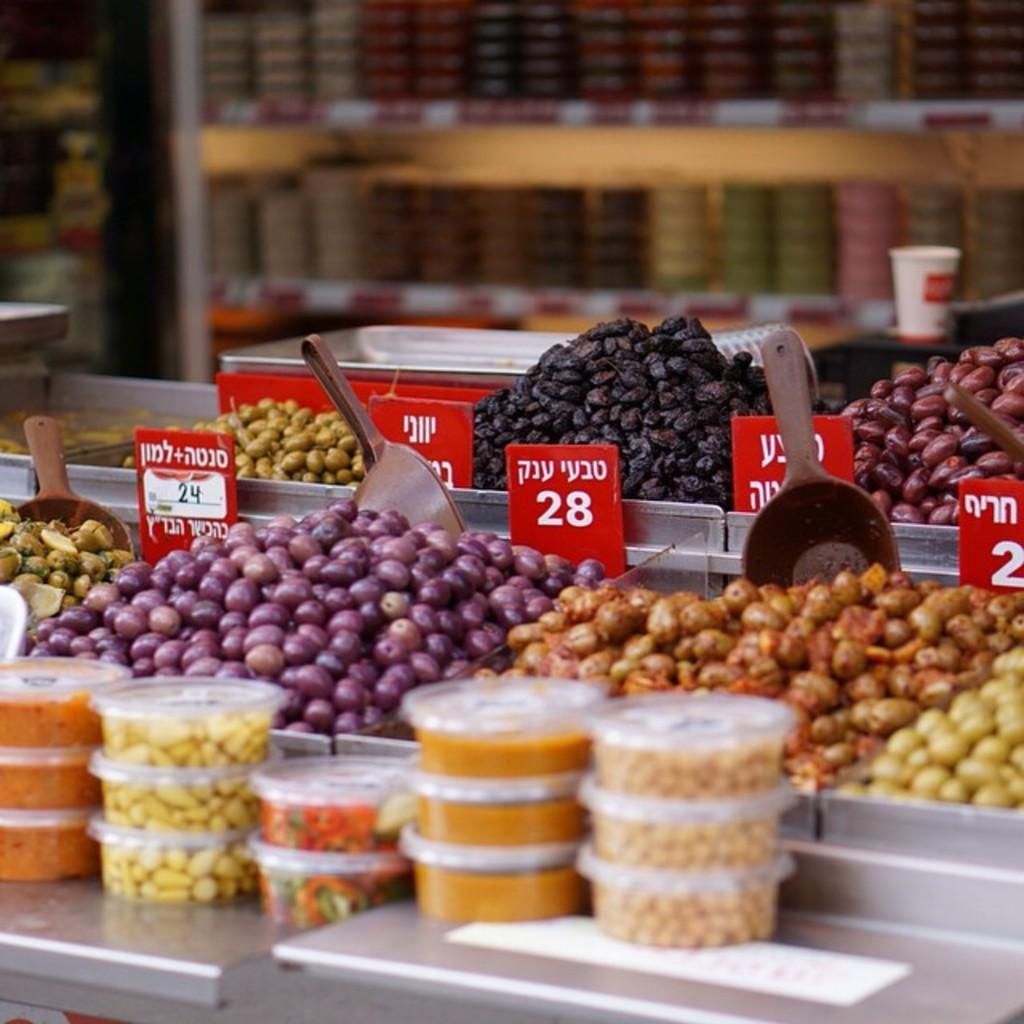Could you give a brief overview of what you see in this image? In this image there are fruits and some are packed in boxes and there are spoons, in the background it is blurred. 